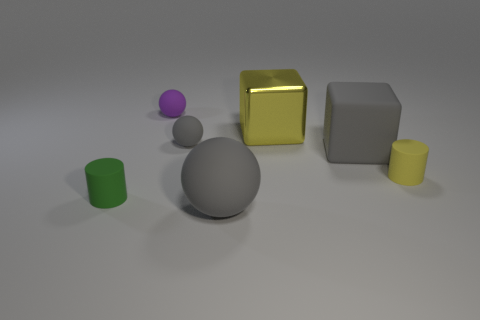Can you describe the arrangement of objects on the table? Certainly! The objects are arranged in a loose group towards the center of the surface, with varying distances between them. There's a large gray sphere, a smaller purple sphere, a yellow cube, a green cylinder, a smaller yellow cylinder, and a medium-sized gray cube. 